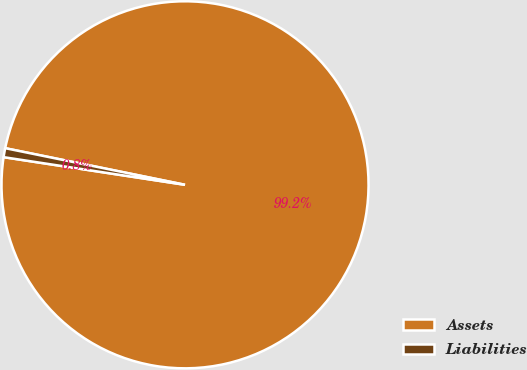<chart> <loc_0><loc_0><loc_500><loc_500><pie_chart><fcel>Assets<fcel>Liabilities<nl><fcel>99.21%<fcel>0.79%<nl></chart> 